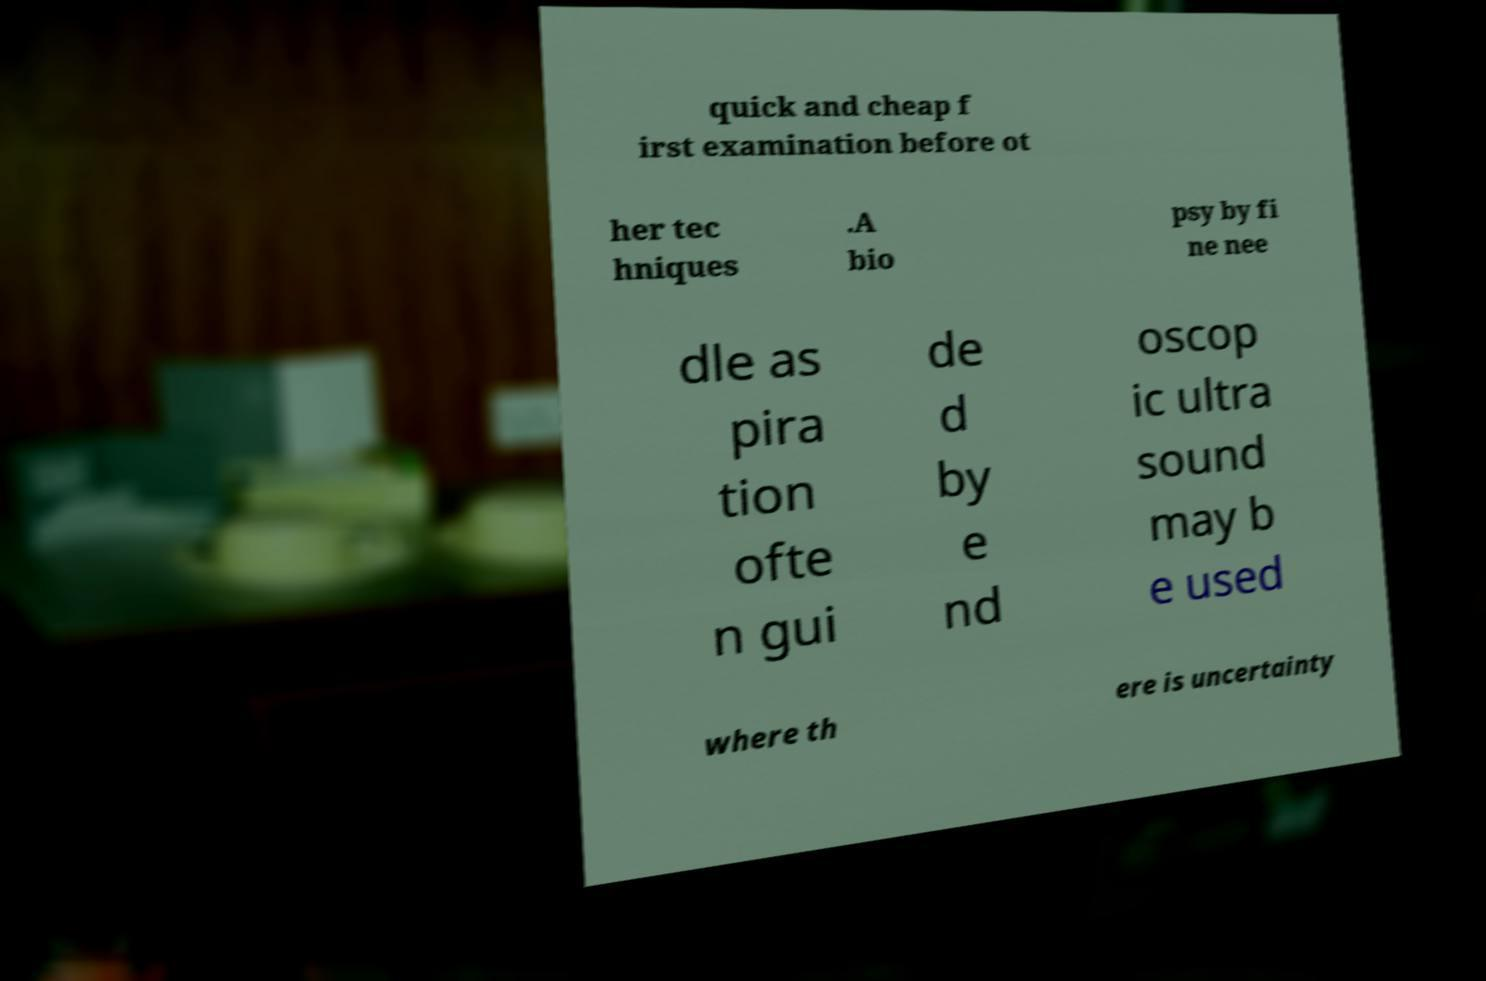Could you assist in decoding the text presented in this image and type it out clearly? quick and cheap f irst examination before ot her tec hniques .A bio psy by fi ne nee dle as pira tion ofte n gui de d by e nd oscop ic ultra sound may b e used where th ere is uncertainty 